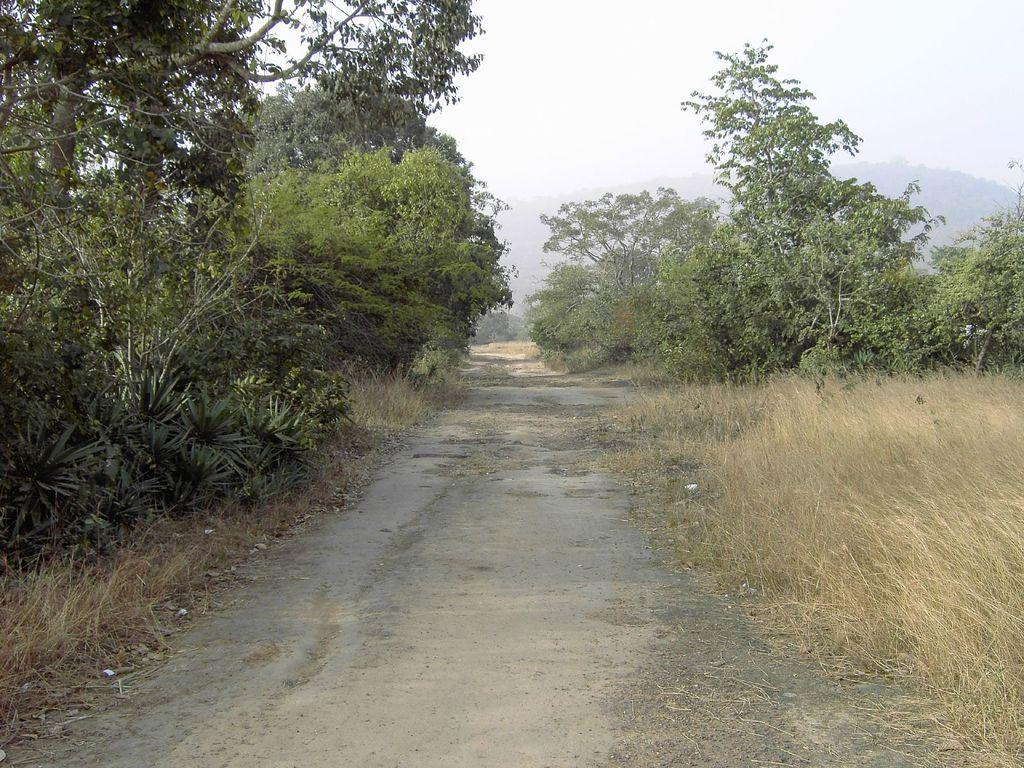What type of vegetation can be seen on the left side of the image? There are trees and grass visible on the left side of the image. What type of vegetation can be seen on the right side of the image? There are trees and grass visible on the right side of the image. What is visible at the top of the image? The sky is visible at the top of the image. What type of division can be seen between the trees and grass on the left side of the image? There is no division between the trees and grass on the left side of the image; they are both visible together. How does the grip of the trees affect the appearance of the image? The grip of the trees does not affect the appearance of the image, as the image does not show any interaction with the trees. 